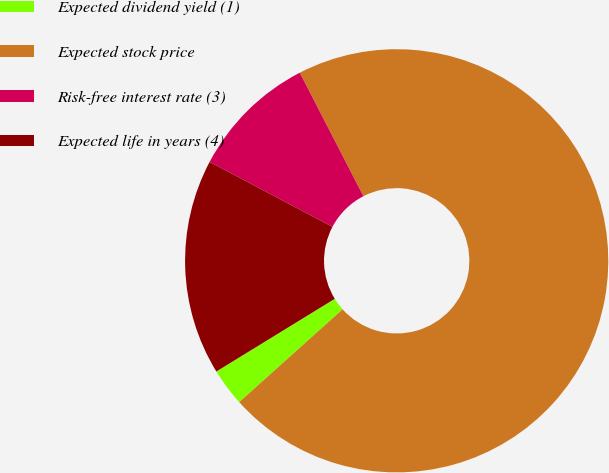Convert chart to OTSL. <chart><loc_0><loc_0><loc_500><loc_500><pie_chart><fcel>Expected dividend yield (1)<fcel>Expected stock price<fcel>Risk-free interest rate (3)<fcel>Expected life in years (4)<nl><fcel>2.88%<fcel>70.93%<fcel>9.69%<fcel>16.5%<nl></chart> 